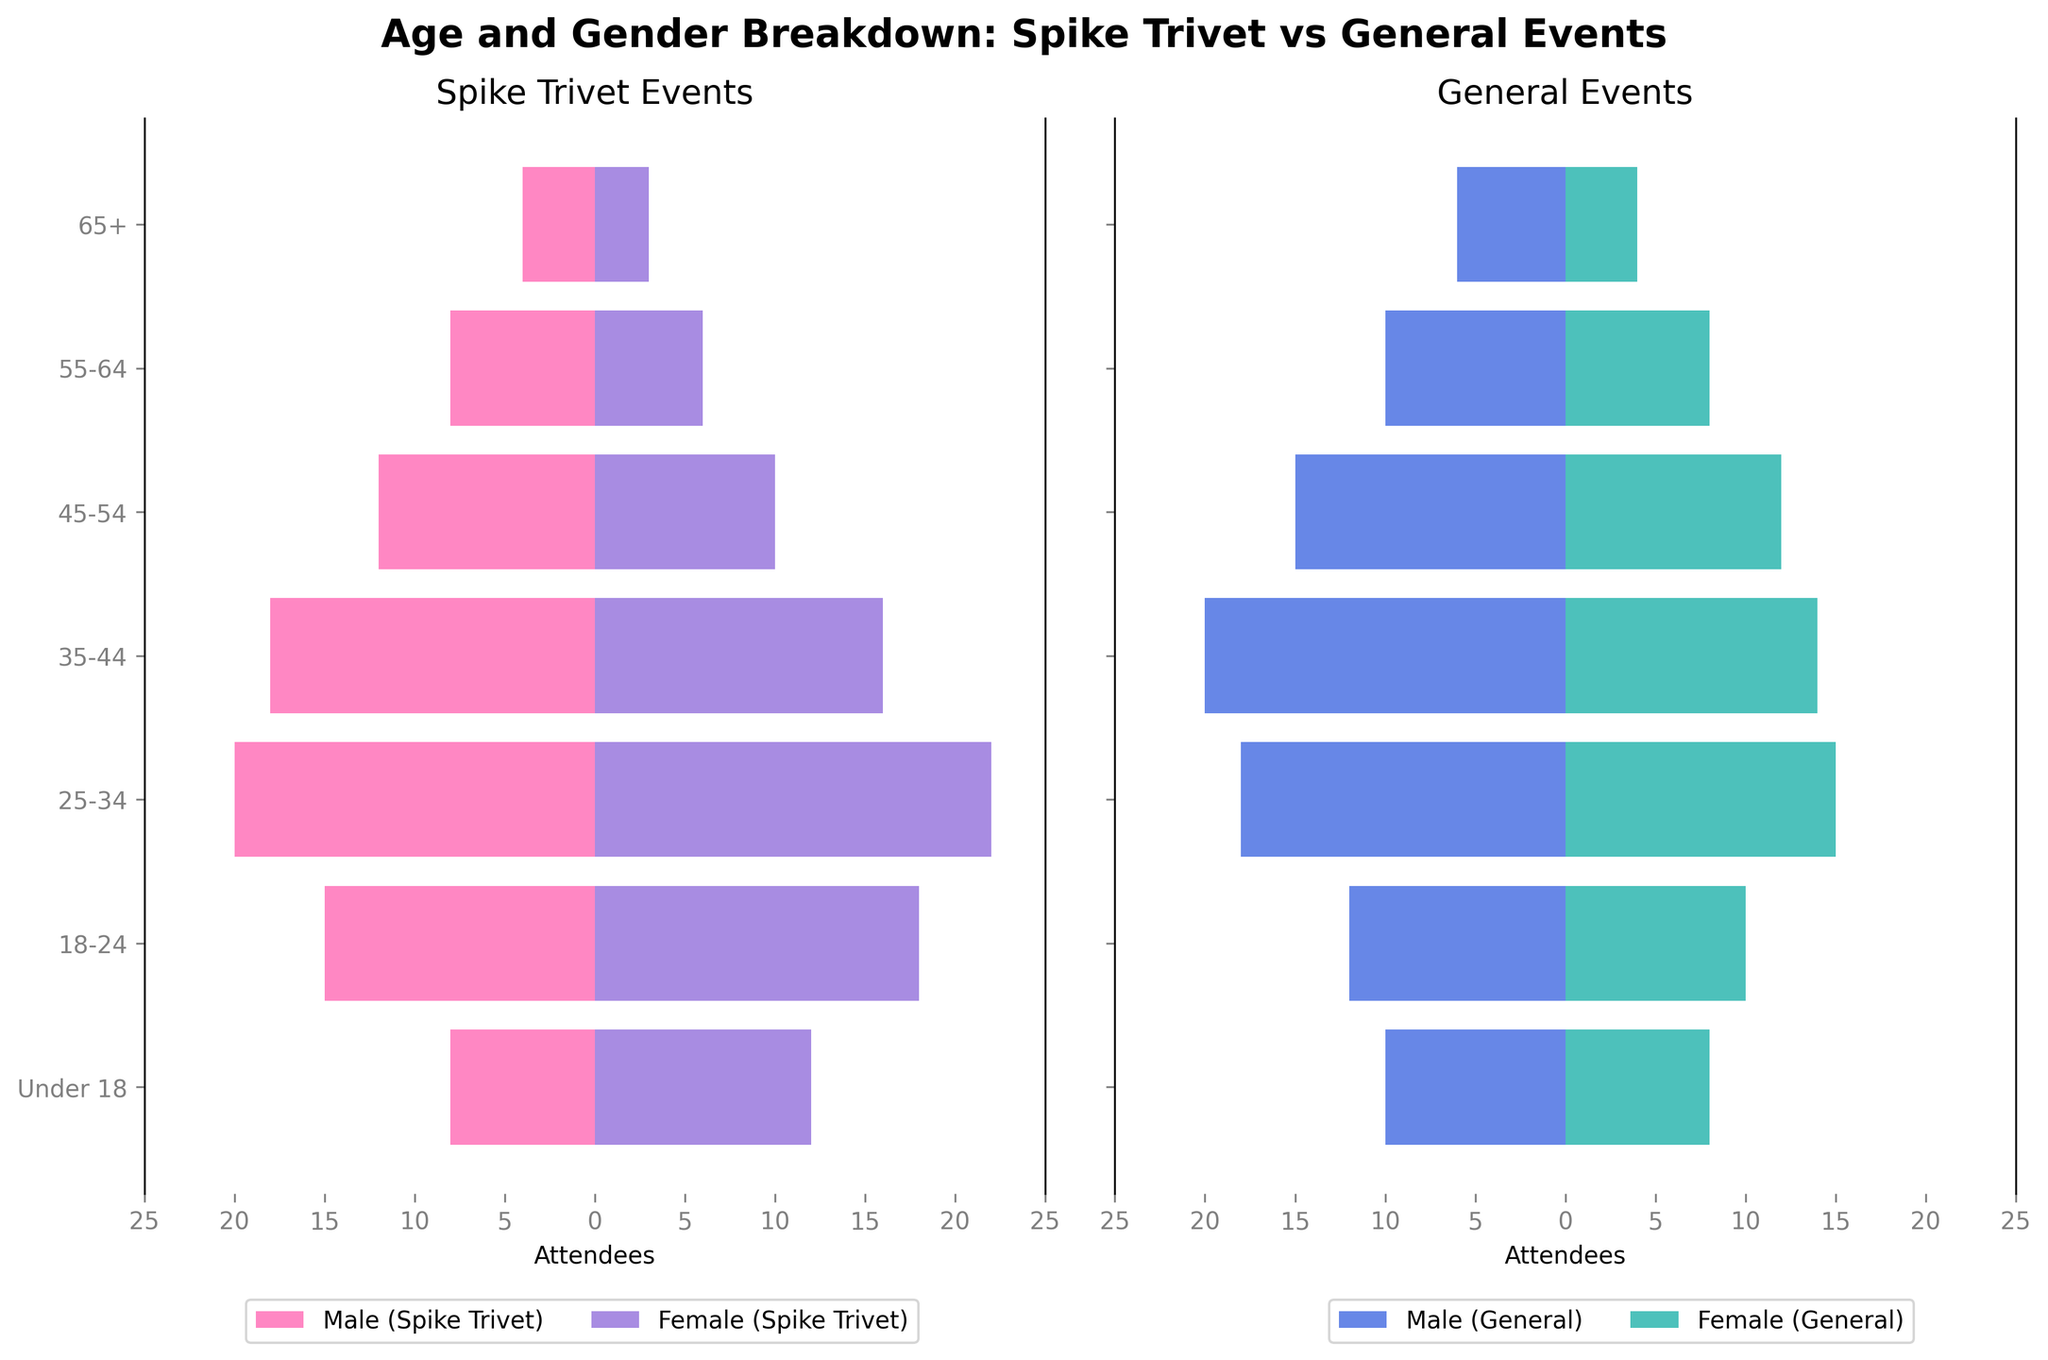What's the overall trend in age distribution for Spike Trivet events? The middle age groups (25-34 and 35-44) have the highest attendance, while the youngest (Under 18) and oldest (65+) age groups have the lowest attendance. This pattern holds for both males and females.
Answer: Middle age groups dominate Is there a significant gender difference in attendees under 18 for Spike Trivet events? Yes, there are more females (12) under 18 attending Spike Trivet events compared to males (8).
Answer: More females How do the 45-54 age groups compare between Spike Trivet events and general wrestling events in terms of male attendance? Spike Trivet events have fewer male attendees (12) compared to general wrestling events (15) in the 45-54 age group.
Answer: Fewer for Trivet events Which gender has the highest number of attendees in the 25-34 age group for Spike Trivet events? Females have the highest number of attendees in the 25-34 age group for Spike Trivet events, numbering 22.
Answer: Females What's the difference in female attendance between Spike Trivet events and general wrestling events in the 35-44 age group? Spike Trivet events have 16 females, whereas general events have 14 females in the 35-44 age group, making a difference of 2 attendees.
Answer: 2 attendees more for Trivet events Are there any age groups where male attendance is equal for both event types? No, there are no age groups where the male attendance is exactly the same for both Spike Trivet and general wrestling events.
Answer: No What can be inferred about the general age preference for Spike Trivet events compared to general wrestling events? The age distribution shows that Spike Trivet events attract more attendees in the 18-24 and 25-34 age groups compared to general wrestling events.
Answer: Younger age preference How do male and female attendees in the 55-64 age group for general wrestling events compare? Both male and female attendees in the 55-64 age group for general wrestling events are equal, with 10 males and 8 females.
Answer: Equal for males, slightly less for females What's the overall gender trend for attendees at general wrestling events compared to Spike Trivet events? General wrestling events have more balanced gender attendance compared to Spike Trivet events, where females consistently outnumber males.
Answer: More balanced for general events In which age group do Spike Trivet events have the smallest difference between male and female attendees? The 65+ age group shows the smallest difference between male and female attendees for Spike Trivet events (4 males vs. 3 females).
Answer: 65+ age group 